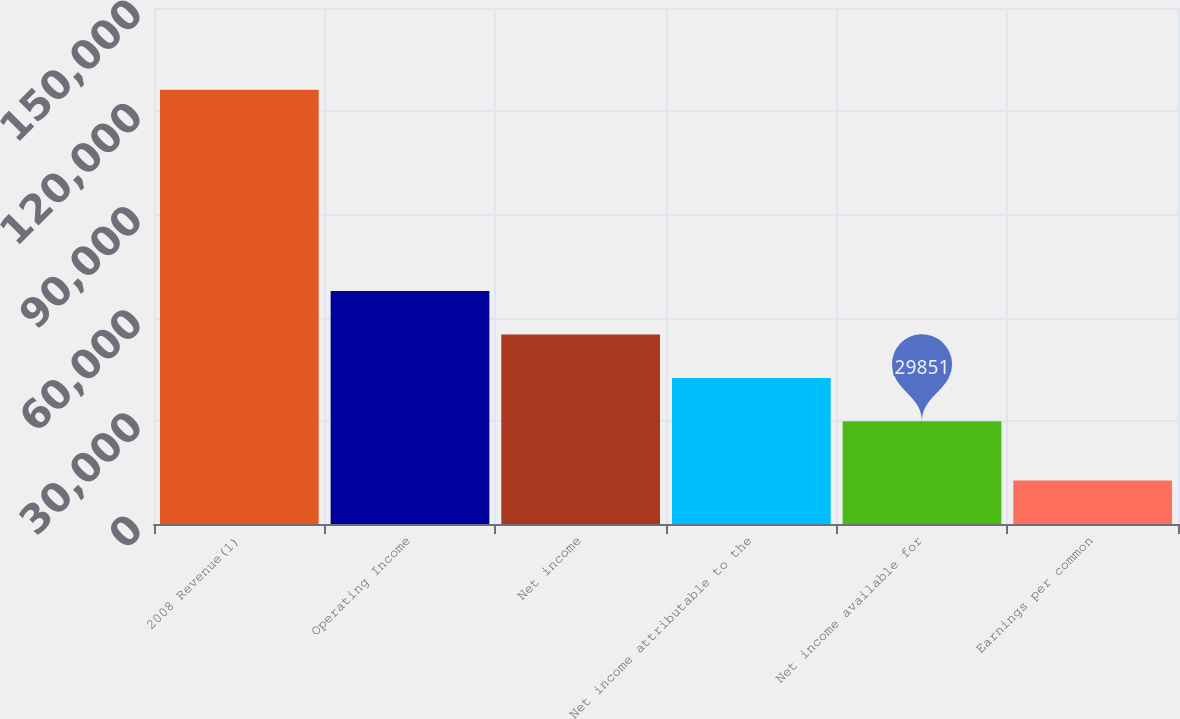Convert chart to OTSL. <chart><loc_0><loc_0><loc_500><loc_500><bar_chart><fcel>2008 Revenue(1)<fcel>Operating Income<fcel>Net income<fcel>Net income attributable to the<fcel>Net income available for<fcel>Earnings per common<nl><fcel>126242<fcel>67723.4<fcel>55099.3<fcel>42475.2<fcel>29851<fcel>12624.7<nl></chart> 